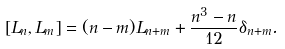<formula> <loc_0><loc_0><loc_500><loc_500>[ L _ { n } , L _ { m } ] = ( n - m ) L _ { n + m } + \frac { n ^ { 3 } - n } { 1 2 } \delta _ { n + m } .</formula> 